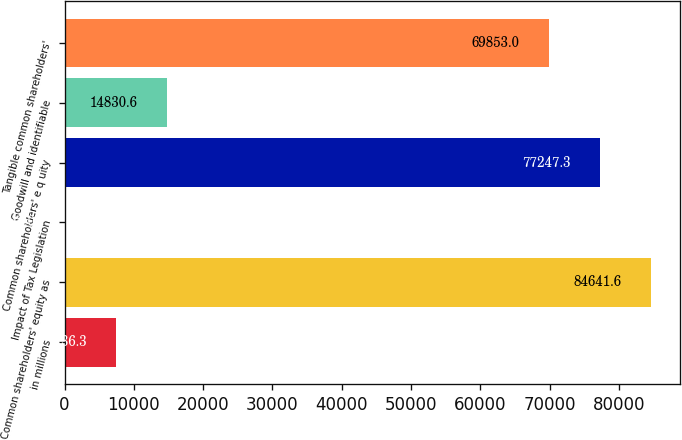Convert chart. <chart><loc_0><loc_0><loc_500><loc_500><bar_chart><fcel>in millions<fcel>Common shareholders' equity as<fcel>Impact of Tax Legislation<fcel>Common shareholders' e q uity<fcel>Goodwill and identifiable<fcel>Tangible common shareholders'<nl><fcel>7436.3<fcel>84641.6<fcel>42<fcel>77247.3<fcel>14830.6<fcel>69853<nl></chart> 